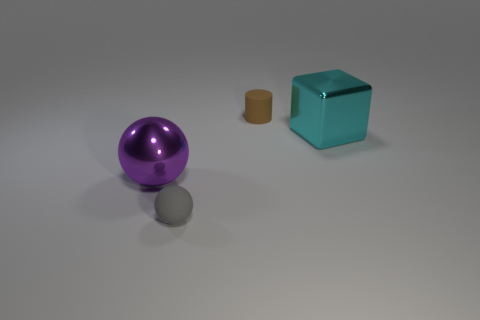Add 1 brown things. How many objects exist? 5 Subtract all cylinders. How many objects are left? 3 Add 3 cylinders. How many cylinders exist? 4 Subtract 0 yellow cubes. How many objects are left? 4 Subtract all small gray matte spheres. Subtract all shiny objects. How many objects are left? 1 Add 2 big metallic objects. How many big metallic objects are left? 4 